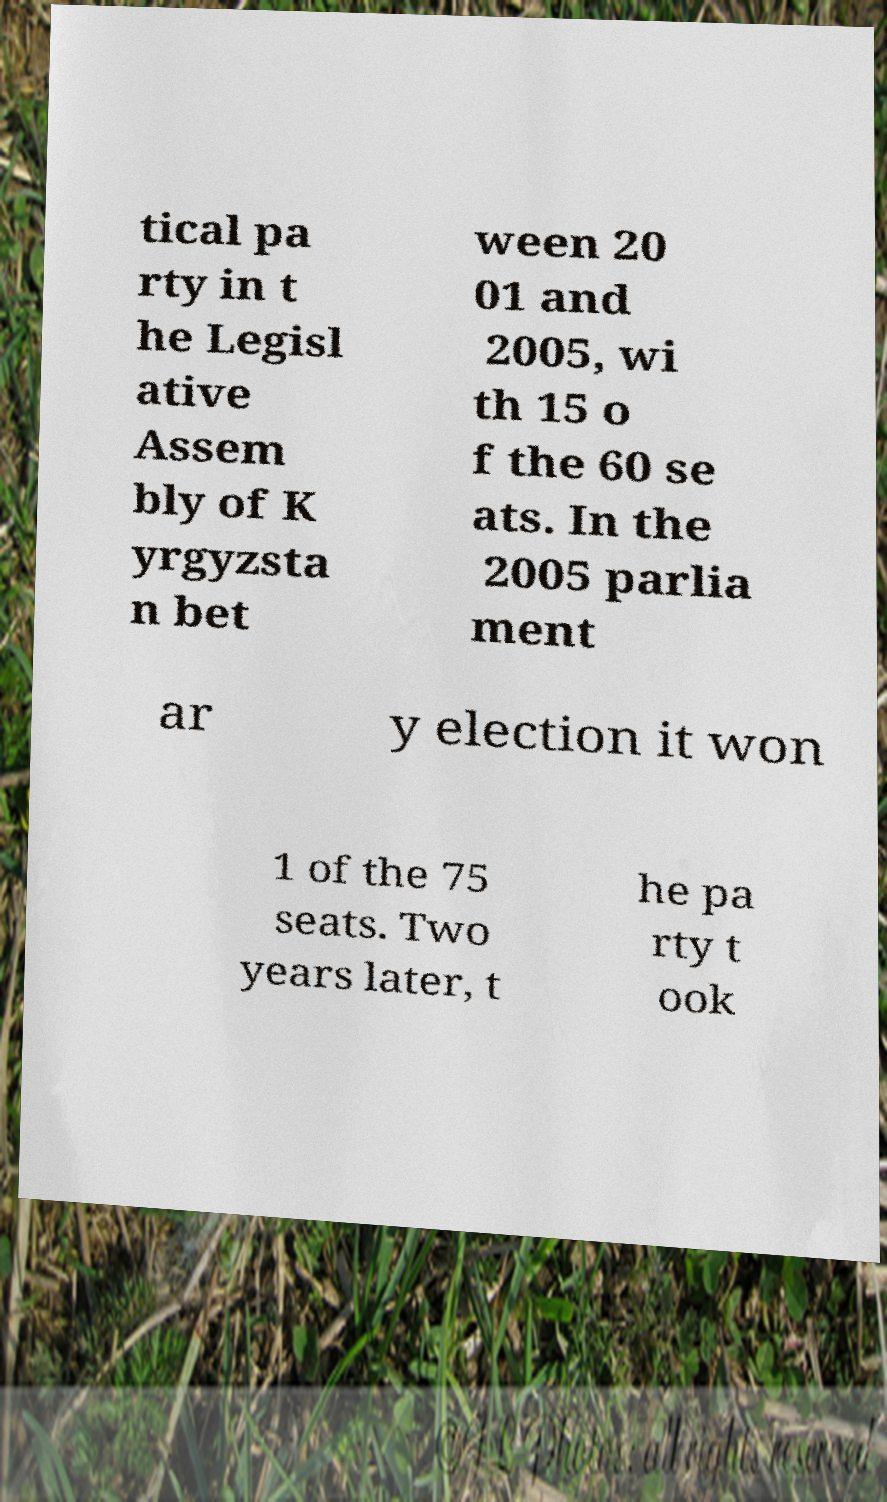Please identify and transcribe the text found in this image. tical pa rty in t he Legisl ative Assem bly of K yrgyzsta n bet ween 20 01 and 2005, wi th 15 o f the 60 se ats. In the 2005 parlia ment ar y election it won 1 of the 75 seats. Two years later, t he pa rty t ook 